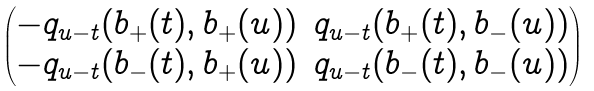<formula> <loc_0><loc_0><loc_500><loc_500>\begin{pmatrix} - q _ { u - t } ( b _ { + } ( t ) , b _ { + } ( u ) ) & q _ { u - t } ( b _ { + } ( t ) , b _ { - } ( u ) ) \\ - q _ { u - t } ( b _ { - } ( t ) , b _ { + } ( u ) ) & q _ { u - t } ( b _ { - } ( t ) , b _ { - } ( u ) ) \\ \end{pmatrix}</formula> 